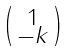<formula> <loc_0><loc_0><loc_500><loc_500>\begin{psmallmatrix} 1 \\ - k \\ \end{psmallmatrix}</formula> 